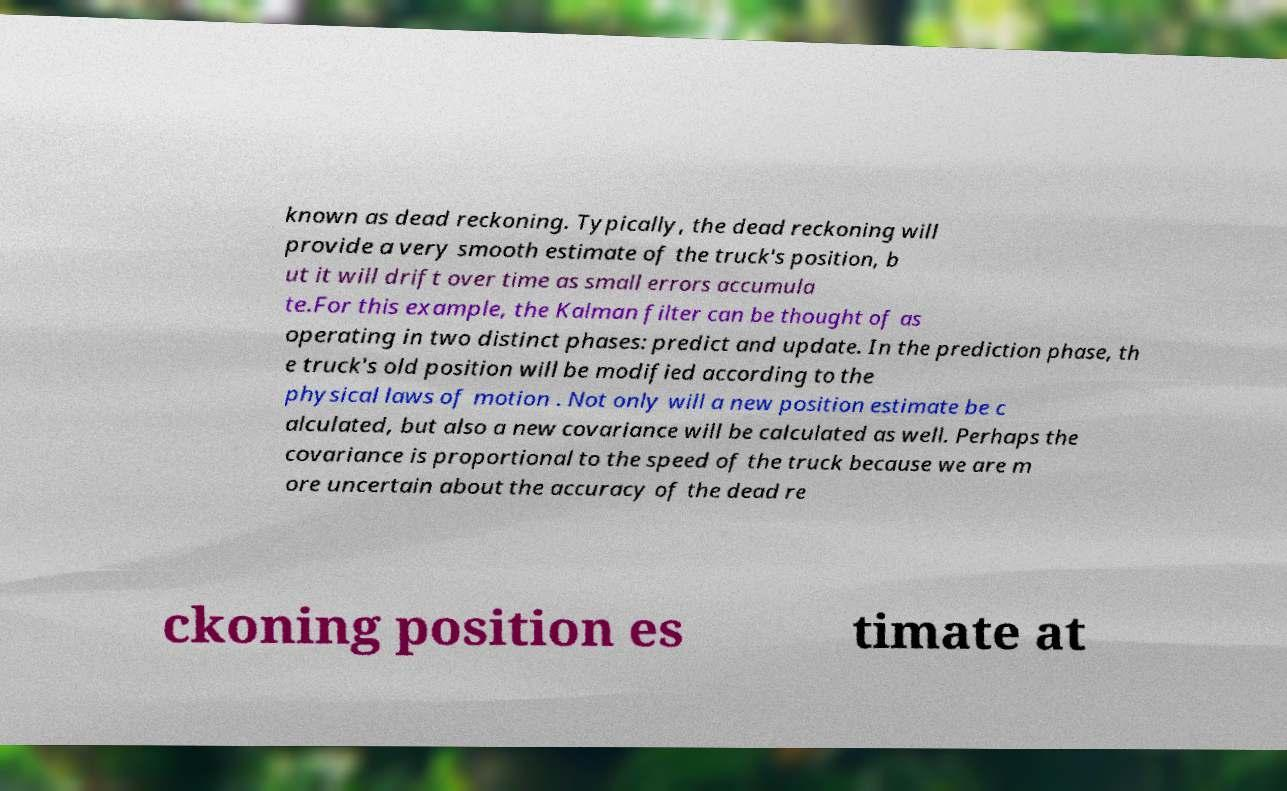I need the written content from this picture converted into text. Can you do that? known as dead reckoning. Typically, the dead reckoning will provide a very smooth estimate of the truck's position, b ut it will drift over time as small errors accumula te.For this example, the Kalman filter can be thought of as operating in two distinct phases: predict and update. In the prediction phase, th e truck's old position will be modified according to the physical laws of motion . Not only will a new position estimate be c alculated, but also a new covariance will be calculated as well. Perhaps the covariance is proportional to the speed of the truck because we are m ore uncertain about the accuracy of the dead re ckoning position es timate at 